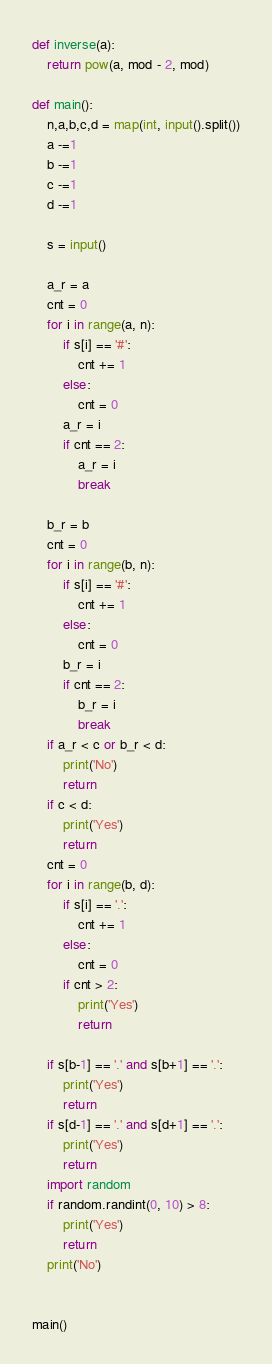<code> <loc_0><loc_0><loc_500><loc_500><_Python_>def inverse(a):
    return pow(a, mod - 2, mod)

def main():
    n,a,b,c,d = map(int, input().split())
    a -=1
    b -=1
    c -=1
    d -=1

    s = input()

    a_r = a
    cnt = 0
    for i in range(a, n):
        if s[i] == '#':
            cnt += 1
        else:
            cnt = 0
        a_r = i
        if cnt == 2:
            a_r = i
            break

    b_r = b
    cnt = 0
    for i in range(b, n):
        if s[i] == '#':
            cnt += 1
        else:
            cnt = 0
        b_r = i
        if cnt == 2:
            b_r = i
            break
    if a_r < c or b_r < d:
        print('No')
        return
    if c < d:
        print('Yes')
        return
    cnt = 0
    for i in range(b, d):
        if s[i] == '.':
            cnt += 1
        else:
            cnt = 0
        if cnt > 2:
            print('Yes')
            return

    if s[b-1] == '.' and s[b+1] == '.':
        print('Yes')
        return
    if s[d-1] == '.' and s[d+1] == '.':
        print('Yes')
        return
    import random
    if random.randint(0, 10) > 8:
        print('Yes')
        return
    print('No')


main()</code> 